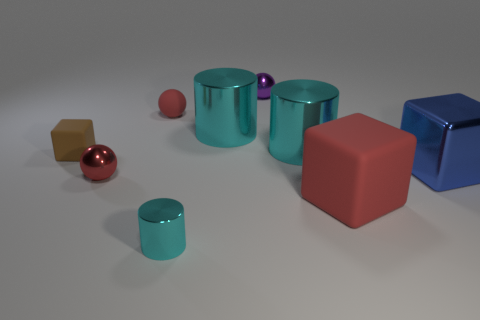Are there any large cubes made of the same material as the small cyan cylinder?
Give a very brief answer. Yes. Does the blue block have the same material as the tiny purple object?
Make the answer very short. Yes. There is a matte object that is the same size as the brown matte cube; what is its color?
Your answer should be compact. Red. How many other objects are the same shape as the red metallic thing?
Provide a short and direct response. 2. Is the size of the blue metallic thing the same as the shiny cylinder on the right side of the purple shiny object?
Provide a succinct answer. Yes. What number of objects are either small red matte objects or cyan cylinders?
Your answer should be very brief. 4. How many other objects are there of the same size as the red rubber cube?
Provide a succinct answer. 3. There is a matte sphere; is its color the same as the tiny shiny thing behind the blue block?
Keep it short and to the point. No. What number of balls are red shiny things or blue metallic objects?
Keep it short and to the point. 1. Is there any other thing of the same color as the small rubber ball?
Your answer should be compact. Yes. 